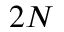Convert formula to latex. <formula><loc_0><loc_0><loc_500><loc_500>2 N</formula> 